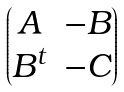Convert formula to latex. <formula><loc_0><loc_0><loc_500><loc_500>\begin{pmatrix} A & - B \\ B ^ { t } & - C \end{pmatrix}</formula> 